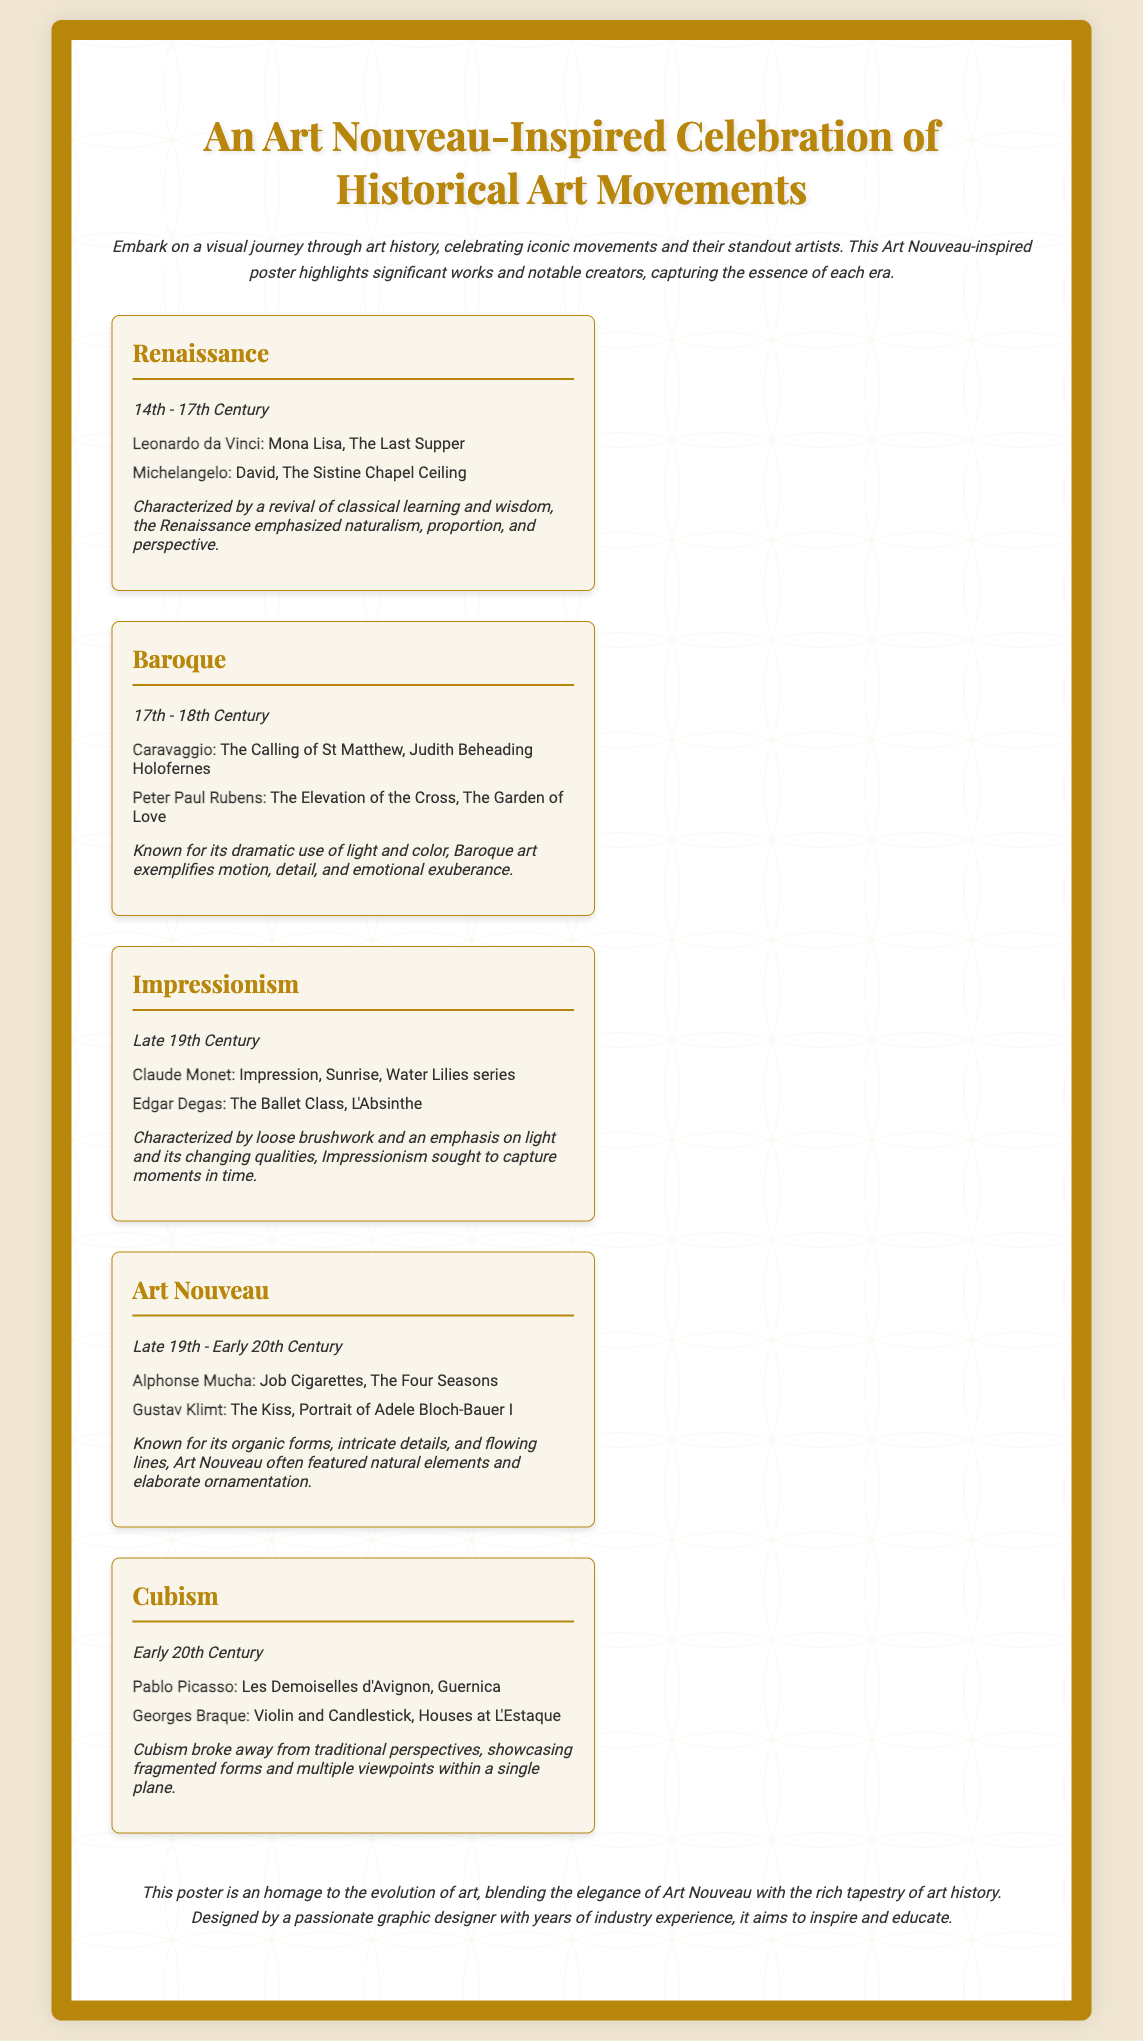What is the title of the poster? The title is prominently displayed at the top of the document and is "An Art Nouveau-Inspired Celebration of Historical Art Movements."
Answer: An Art Nouveau-Inspired Celebration of Historical Art Movements Who created the "Mona Lisa"? The artist associated with the "Mona Lisa" is listed under the Renaissance movement.
Answer: Leonardo da Vinci What time period does Impressionism cover? The time period for Impressionism is specified in the document, identifying it as "Late 19th Century."
Answer: Late 19th Century Which artist is known for "The Kiss"? The artist recognized for "The Kiss" is mentioned in connection with Art Nouveau.
Answer: Gustav Klimt What are two notable works of Pablo Picasso? The document cites two distinguished artworks by Pablo Picasso under the Cubism movement.
Answer: Les Demoiselles d'Avignon, Guernica How many movements are featured in the poster? The poster lists five distinct art movements that are highlighted.
Answer: Five What styles does the Baroque movement emphasize? The highlights about the Baroque movement indicate its focus on light, color, motion, detail, and emotional exuberance.
Answer: Light and color What design aesthetic influences the poster? The poster is influenced by a specific art style that is mentioned in its title.
Answer: Art Nouveau What is the footer's primary message? The footer conveys a sentiment about the purpose and inspiration behind the poster.
Answer: An homage to the evolution of art 